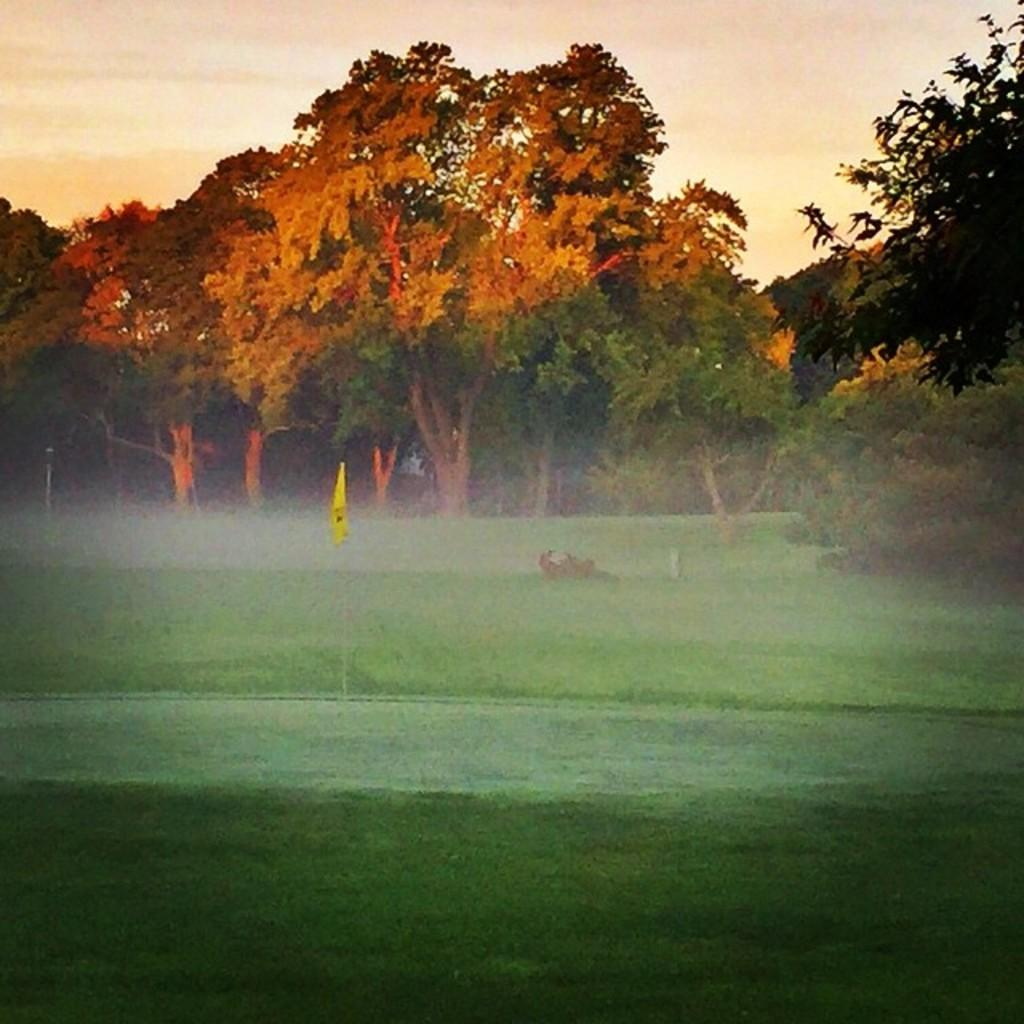What type of vegetation is present in the image? There are trees in the image. What colors can be seen on the trees? The trees have yellow, orange, and green colors. What can be found in the garden in the image? There is a yellow color flag in the garden. What is the color of the sky in the image? The sky appears to be white in color. How many birds are participating in the competition in the image? There is no competition or birds present in the image. What type of body is visible in the image? There is no body visible in the image; it features trees, a flag, and a sky. 